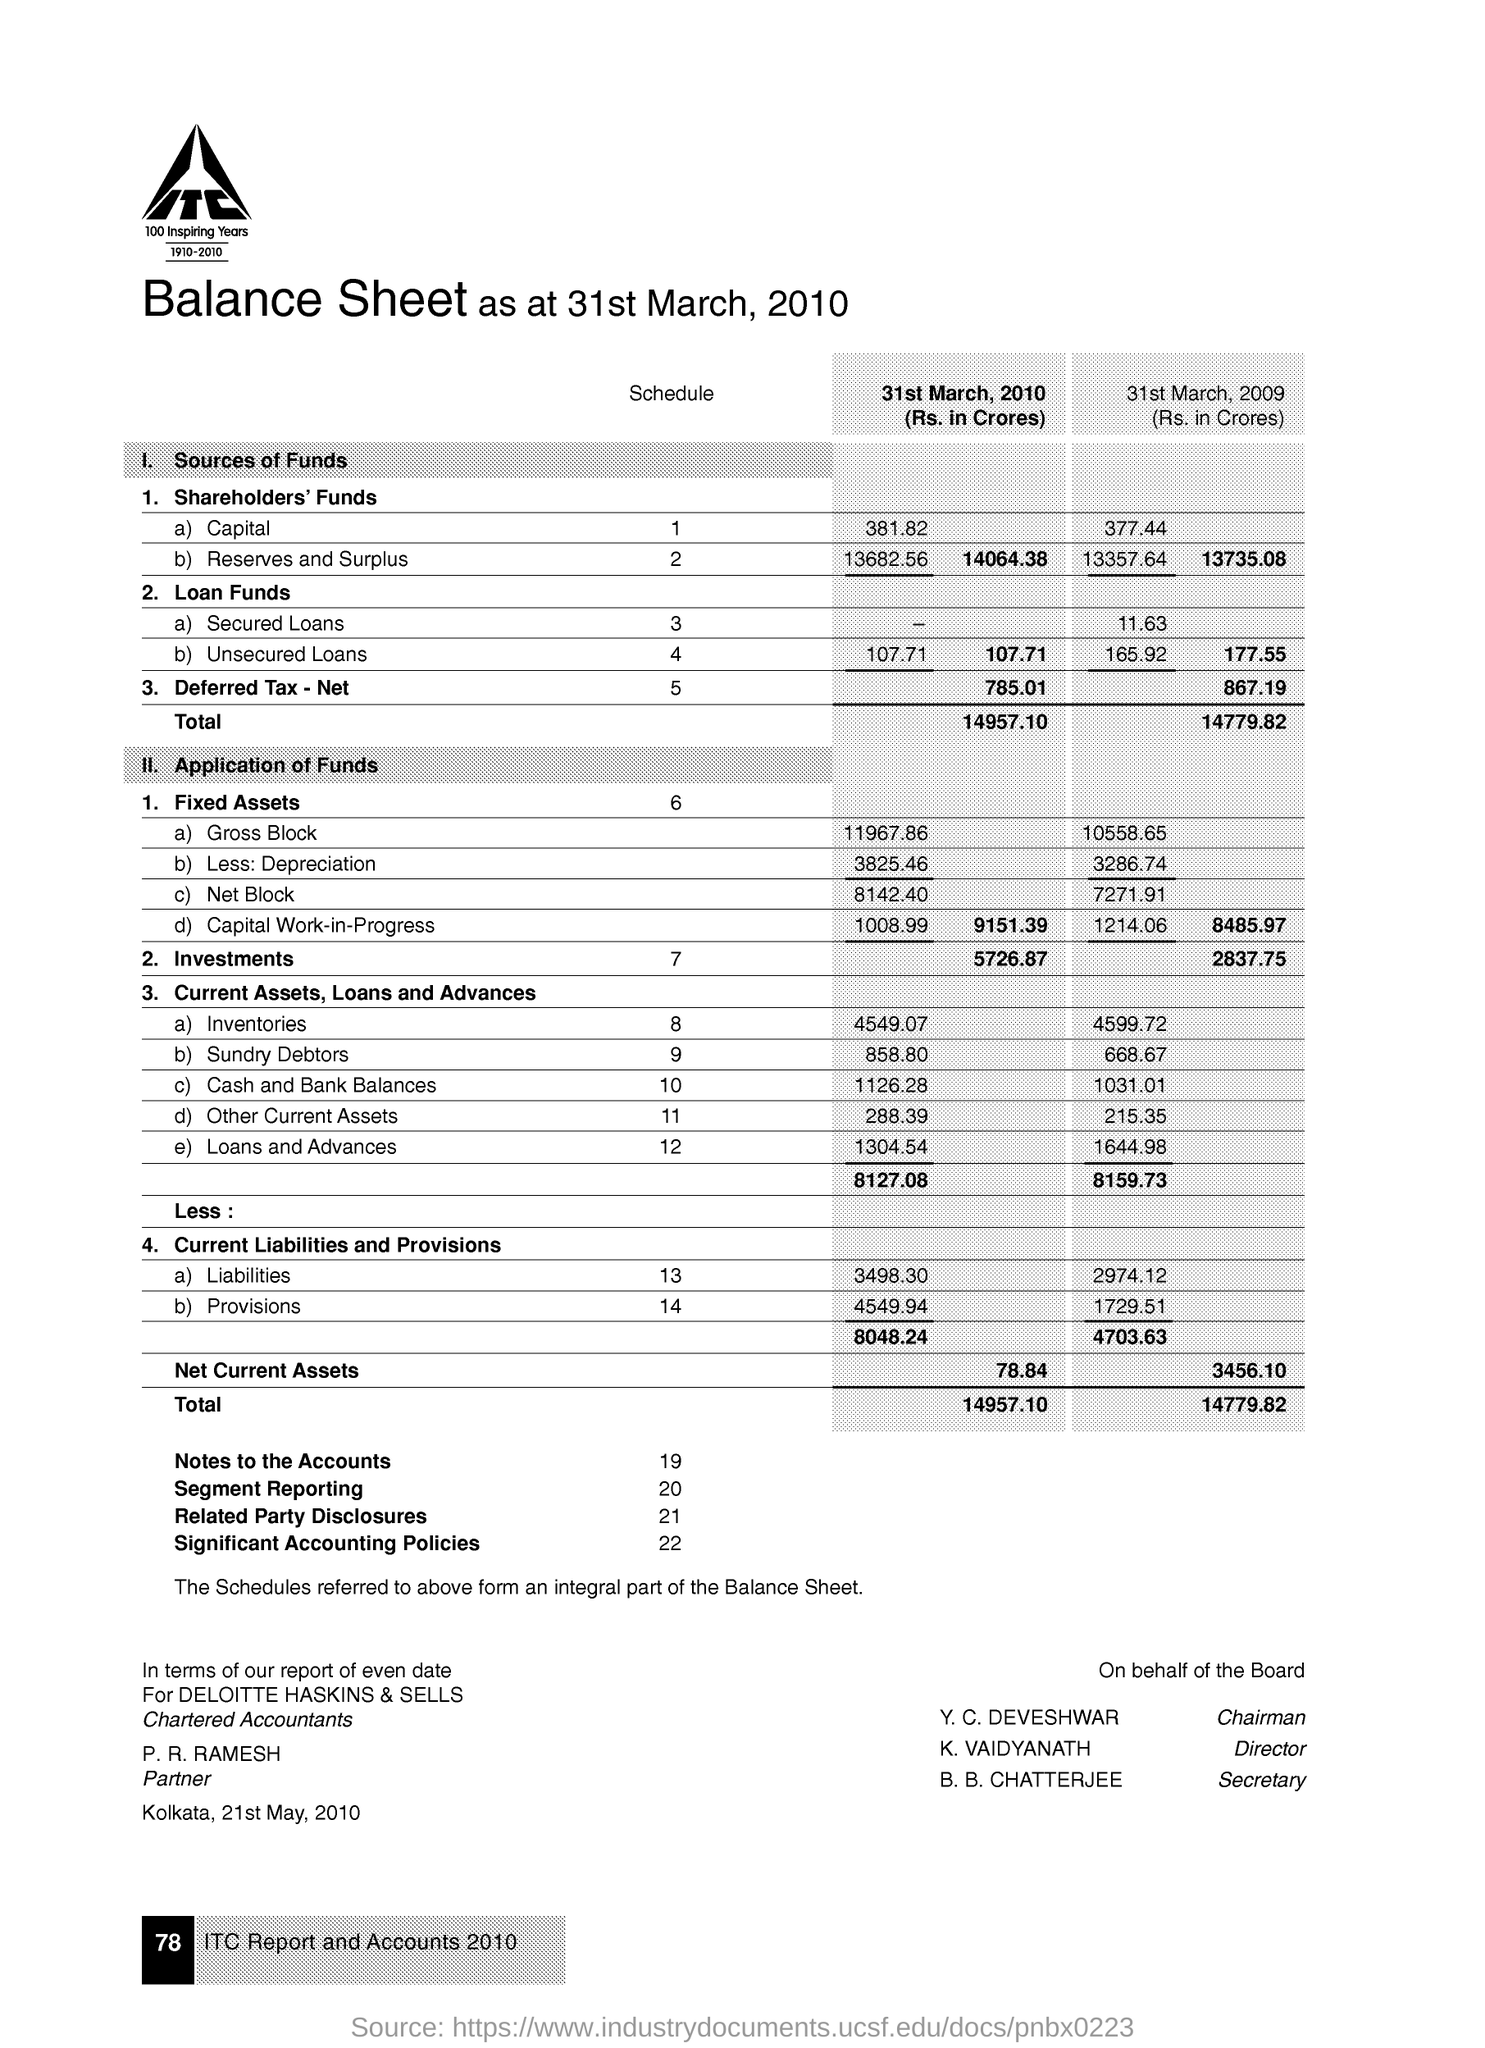List a handful of essential elements in this visual. The net block in fixed assets as on March 31, 2010, was Rs. 8142.40 crores. As of March 31st, 2010, the shareholder's funds capital was Rs. 381.82 crores. As of March 31, 2010, the gross block for fixed assets was 11967.86 crores. As of March 31, 2010, the total investments were 5,726.87 crores. 